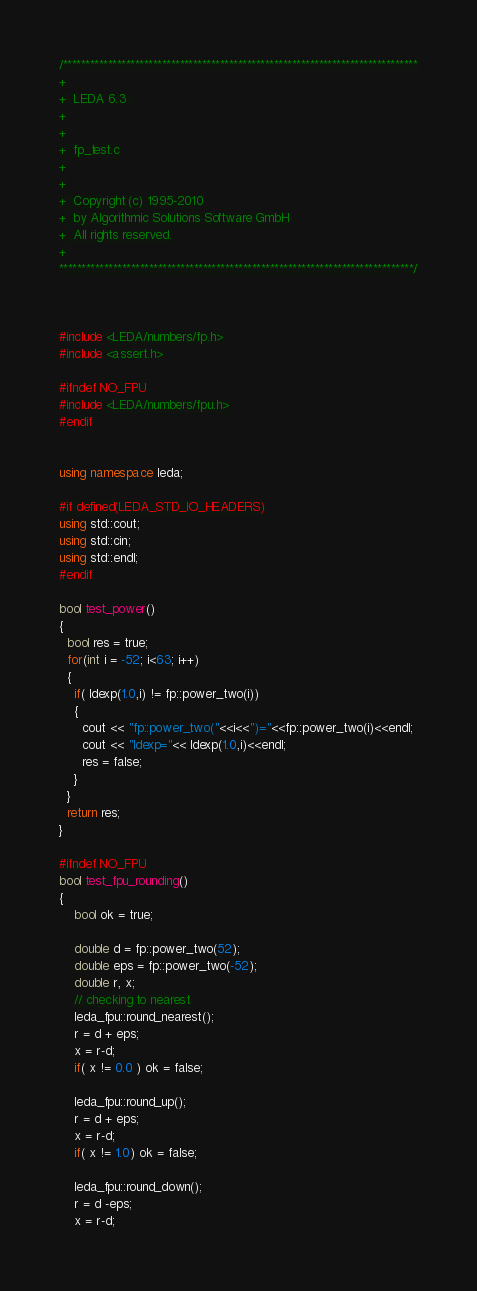<code> <loc_0><loc_0><loc_500><loc_500><_C++_>/*******************************************************************************
+
+  LEDA 6.3  
+
+
+  fp_test.c
+
+
+  Copyright (c) 1995-2010
+  by Algorithmic Solutions Software GmbH
+  All rights reserved.
+ 
*******************************************************************************/



#include <LEDA/numbers/fp.h>
#include <assert.h>

#ifndef NO_FPU
#include <LEDA/numbers/fpu.h>
#endif


using namespace leda;

#if defined(LEDA_STD_IO_HEADERS)
using std::cout;
using std::cin;
using std::endl;
#endif

bool test_power()
{
  bool res = true;
  for(int i = -52; i<63; i++)
  {
    if( ldexp(1.0,i) != fp::power_two(i))
    {
      cout << "fp::power_two("<<i<<")="<<fp::power_two(i)<<endl;
      cout << "ldexp="<< ldexp(1.0,i)<<endl;
      res = false;
    }
  }
  return res;
}

#ifndef NO_FPU
bool test_fpu_rounding()
{
	bool ok = true;

	double d = fp::power_two(52);
	double eps = fp::power_two(-52);
	double r, x;
	// checking to nearest
	leda_fpu::round_nearest();
	r = d + eps;
	x = r-d;
	if( x != 0.0 ) ok = false;

	leda_fpu::round_up();
	r = d + eps;
	x = r-d;
	if( x != 1.0) ok = false;

	leda_fpu::round_down();
	r = d -eps;
	x = r-d;</code> 